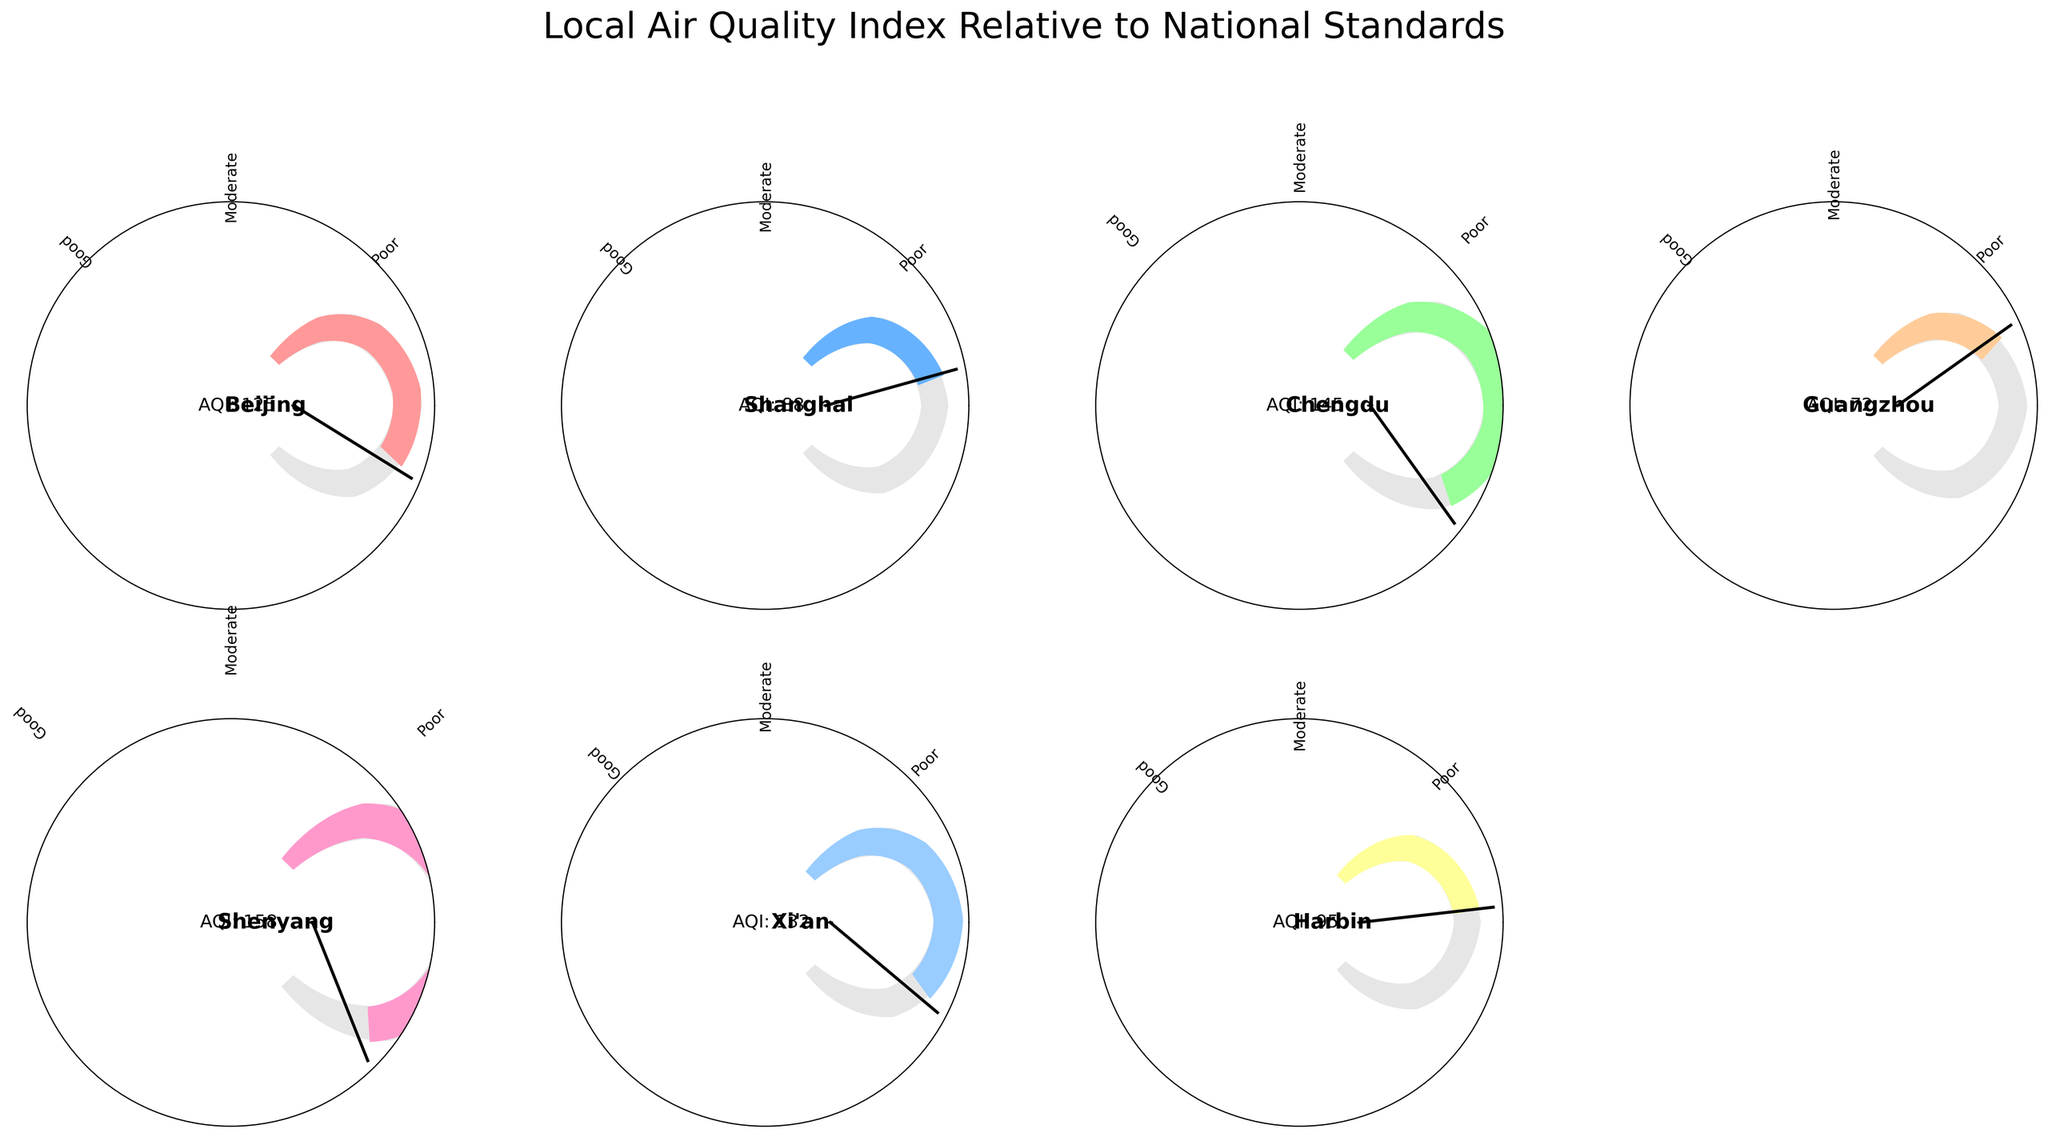What city has the highest AQI? The city with the highest AQI can be determined by comparing the AQI values shown on the gauges. Shenyang has a gauge indicating AQI 158, which is the highest value.
Answer: Shenyang Which city has the lowest AQI? The city with the lowest AQI can be determined by comparing the AQI values shown on the gauges. Guangzhou has a gauge indicating AQI 72, which is the lowest value.
Answer: Guangzhou How many cities have an AQI higher than the national standard? By visual inspection of the gauges, we count the cities where the AQI value exceeds the national standard of 100. The cities are Beijing, Chengdu, Shenyang, and Xi'an.
Answer: 4 Which city is closest to the national AQI standard? The city closest to the national AQI standard can be found by looking at the gauges and identifying the AQI closest to 100. Harbin has an AQI of 95, which is closest to 100.
Answer: Harbin What is the difference in AQI between Beijing and Guangzhou? To find the difference in AQI between Beijing and Guangzhou, subtract the AQI of Guangzhou (72) from the AQI of Beijing (125). 125 - 72 = 53.
Answer: 53 If we average the AQI values of Beijing, Chengdu, and Xi'an, what is the result? To find the average AQI, add the AQI values of Beijing (125), Chengdu (145), and Xi'an (132) and divide by 3. (125 + 145 + 132) / 3 = 134.
Answer: 134 Which city has the AQI value furthest from the national standard? The city with the AQI value furthest from the national standard can be found by calculating the absolute difference from 100 for each city. Shenyang has the greatest difference with an AQI of 158, which is 58 higher than 100.
Answer: Shenyang How many cities have an AQI classified as "Poor"? "Poor" AQI classification would be on the rightmost part of each gauge. Cities with AQI significantly exceeding 100 are likely classified as "Poor". Beijing, Chengdu, Shenyang, and Xi'an fit this classification.
Answer: 4 